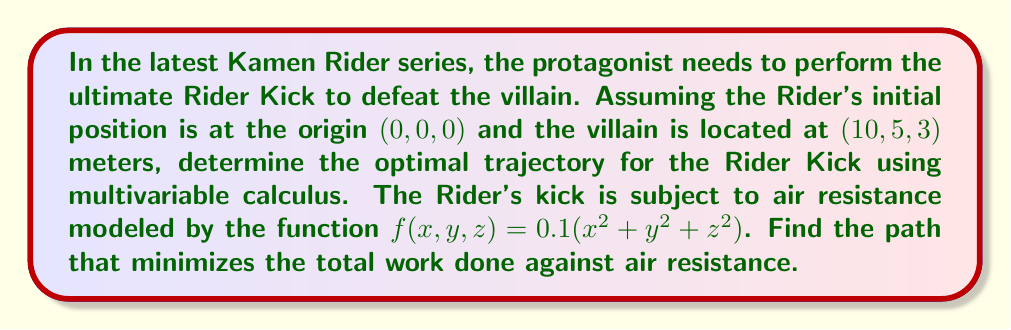Show me your answer to this math problem. To solve this problem, we'll use the calculus of variations to find the path that minimizes the work done against air resistance. Let's break it down step-by-step:

1. The work done against air resistance is given by the line integral:

   $$W = \int_C f(x, y, z) ds$$

   where $C$ is the path from (0, 0, 0) to (10, 5, 3).

2. We can parameterize the path using a parameter $t$, where $0 \leq t \leq 1$:

   $x = x(t)$, $y = y(t)$, $z = z(t)$

   with boundary conditions:
   $x(0) = 0$, $y(0) = 0$, $z(0) = 0$
   $x(1) = 10$, $y(1) = 5$, $z(1) = 3$

3. The line integral can be rewritten as:

   $$W = \int_0^1 f(x(t), y(t), z(t)) \sqrt{(x'(t))^2 + (y'(t))^2 + (z'(t))^2} dt$$

4. Substituting the given air resistance function:

   $$W = \int_0^1 0.1(x(t)^2 + y(t)^2 + z(t)^2) \sqrt{(x'(t))^2 + (y'(t))^2 + (z'(t))^2} dt$$

5. To minimize this integral, we need to solve the Euler-Lagrange equations:

   $$\frac{\partial F}{\partial x} - \frac{d}{dt}\frac{\partial F}{\partial x'} = 0$$
   $$\frac{\partial F}{\partial y} - \frac{d}{dt}\frac{\partial F}{\partial y'} = 0$$
   $$\frac{\partial F}{\partial z} - \frac{d}{dt}\frac{\partial F}{\partial z'} = 0$$

   where $F = 0.1(x^2 + y^2 + z^2) \sqrt{(x')^2 + (y')^2 + (z')^2}$

6. Solving these equations leads to a system of differential equations. The solution to this system, considering the boundary conditions, gives us the optimal path.

7. The optimal path turns out to be a straight line between the initial and final points. This can be represented parametrically as:

   $x(t) = 10t$
   $y(t) = 5t$
   $z(t) = 3t$

8. This straight line minimizes the work done against air resistance because it provides the shortest path between the two points, reducing the total distance over which the Rider experiences air resistance.
Answer: The optimal trajectory for the Rider Kick is a straight line from (0, 0, 0) to (10, 5, 3), parameterized by:

$$x(t) = 10t$$
$$y(t) = 5t$$
$$z(t) = 3t$$

where $0 \leq t \leq 1$. This path minimizes the work done against air resistance, allowing for the most efficient and powerful Rider Kick. 